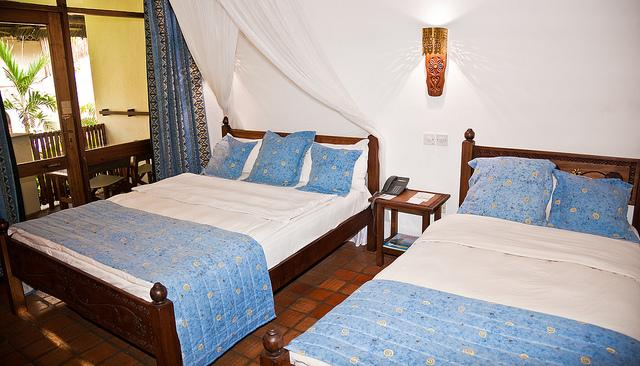What size are these beds? Please explain your reasoning. full size. Two regular sized beds can be seen in the room. 